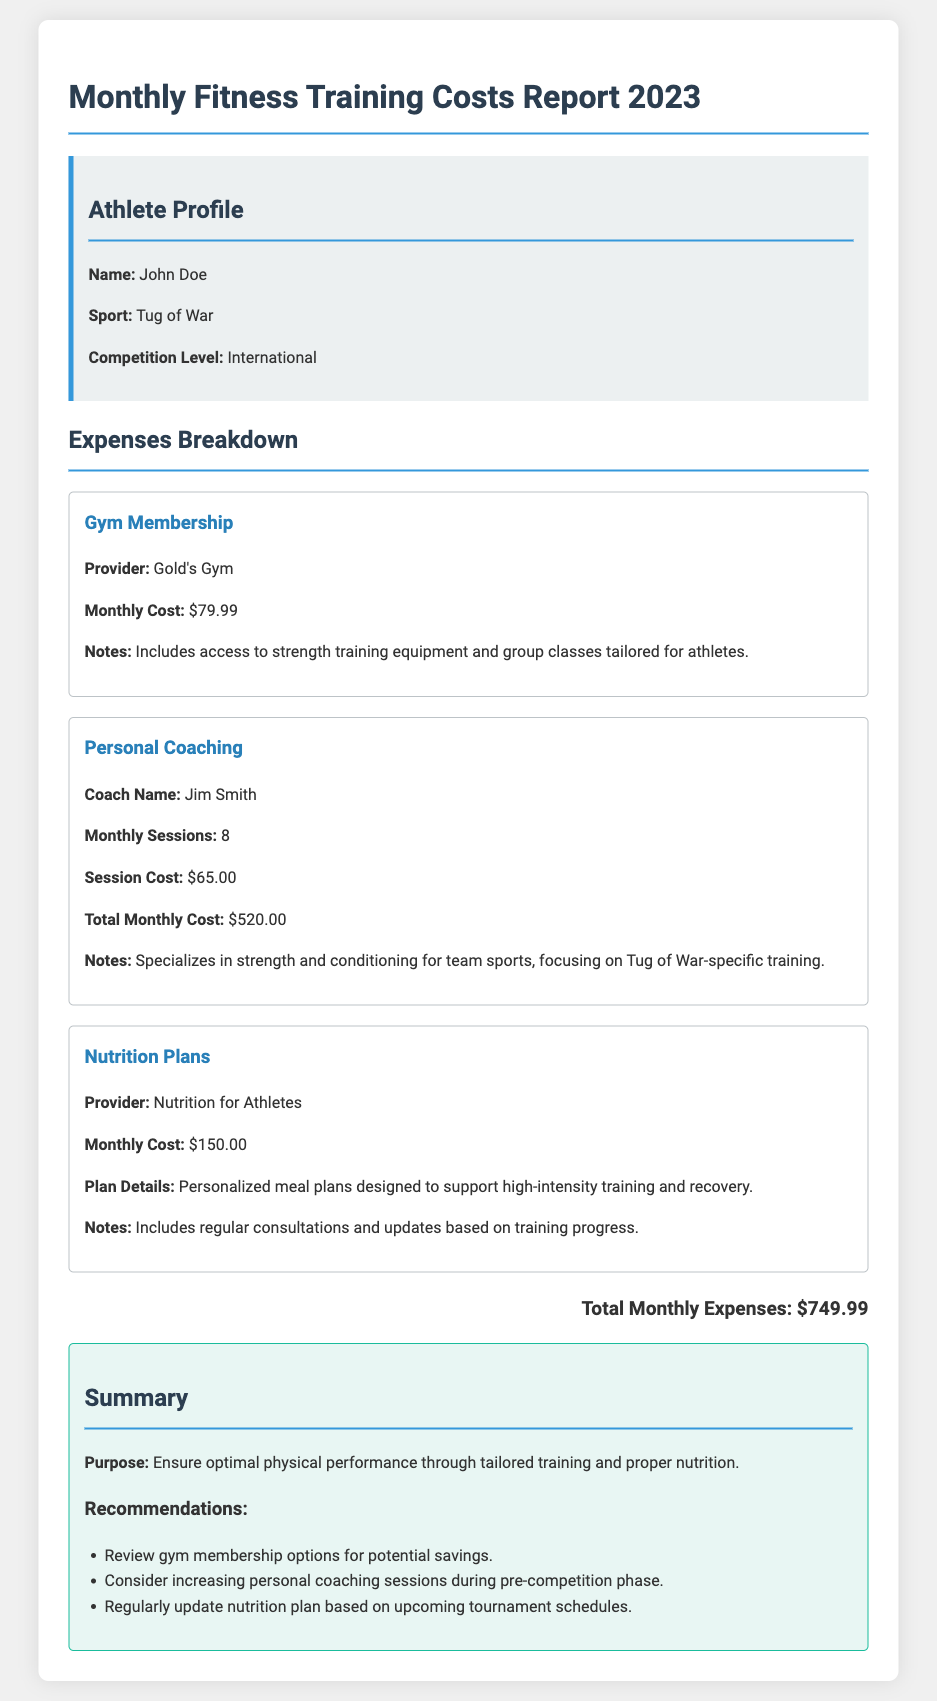what is the monthly cost for gym membership? The gym membership monthly cost is stated in the document as $79.99.
Answer: $79.99 how many personal coaching sessions are conducted monthly? The document specifies that there are 8 personal coaching sessions each month.
Answer: 8 who is the personal coach listed in the report? The name of the personal coach provided in the document is Jim Smith.
Answer: Jim Smith what is the total monthly expense? The total monthly expenses are calculated and presented as $749.99.
Answer: $749.99 what provider offers the nutrition plans? The nutrition plans are provided by Nutrition for Athletes, as mentioned in the document.
Answer: Nutrition for Athletes what is the session cost for personal coaching? The document indicates that the personal coaching session cost is $65.00.
Answer: $65.00 what type of services does Gold's Gym offer according to the report? The document notes that Gold's Gym includes access to strength training equipment and group classes tailored for athletes.
Answer: strength training equipment and group classes what is the purpose of this monthly fitness training costs report? The purpose is stated in the summary section as ensuring optimal physical performance through tailored training and proper nutrition.
Answer: ensure optimal physical performance how much does the nutrition plan cost monthly? The monthly cost for the nutrition plan is detailed in the document as $150.00.
Answer: $150.00 